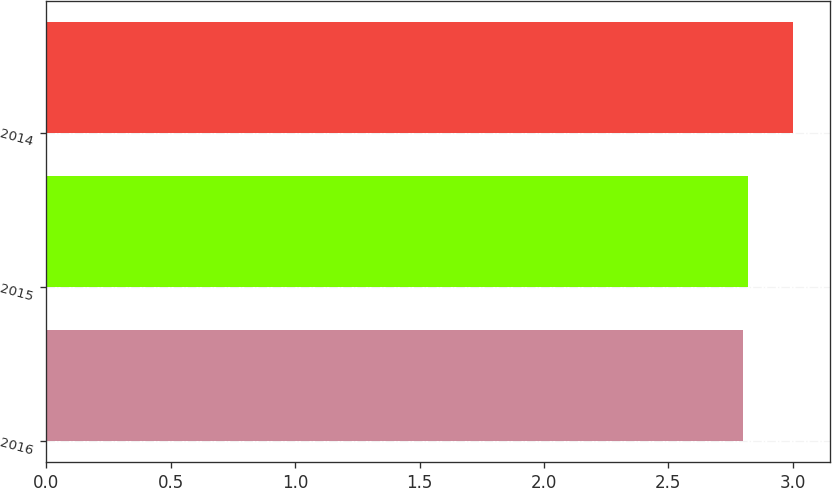<chart> <loc_0><loc_0><loc_500><loc_500><bar_chart><fcel>2016<fcel>2015<fcel>2014<nl><fcel>2.8<fcel>2.82<fcel>3<nl></chart> 